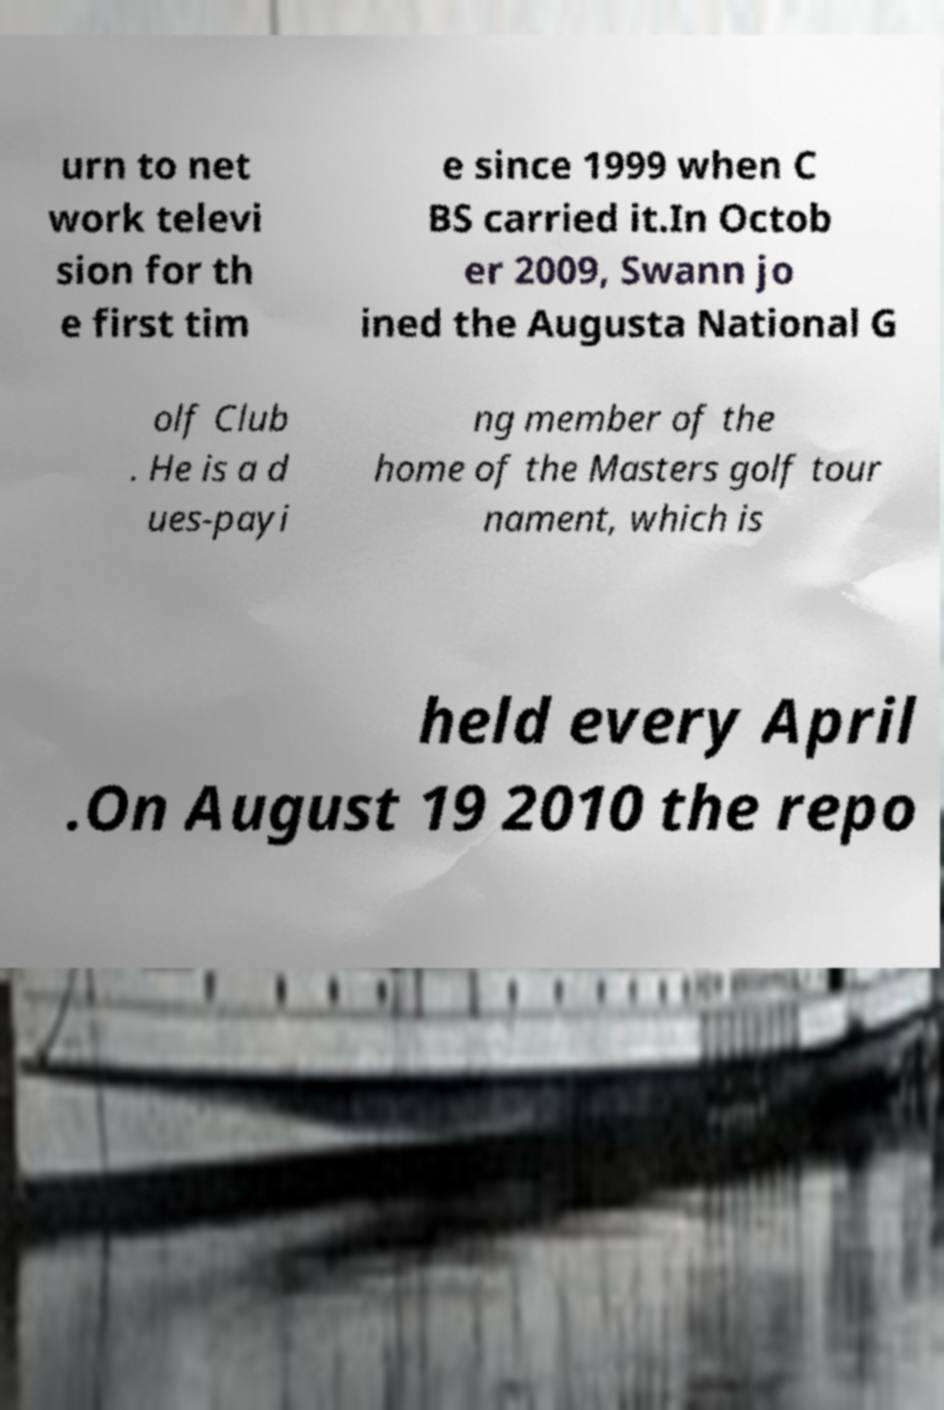What messages or text are displayed in this image? I need them in a readable, typed format. urn to net work televi sion for th e first tim e since 1999 when C BS carried it.In Octob er 2009, Swann jo ined the Augusta National G olf Club . He is a d ues-payi ng member of the home of the Masters golf tour nament, which is held every April .On August 19 2010 the repo 